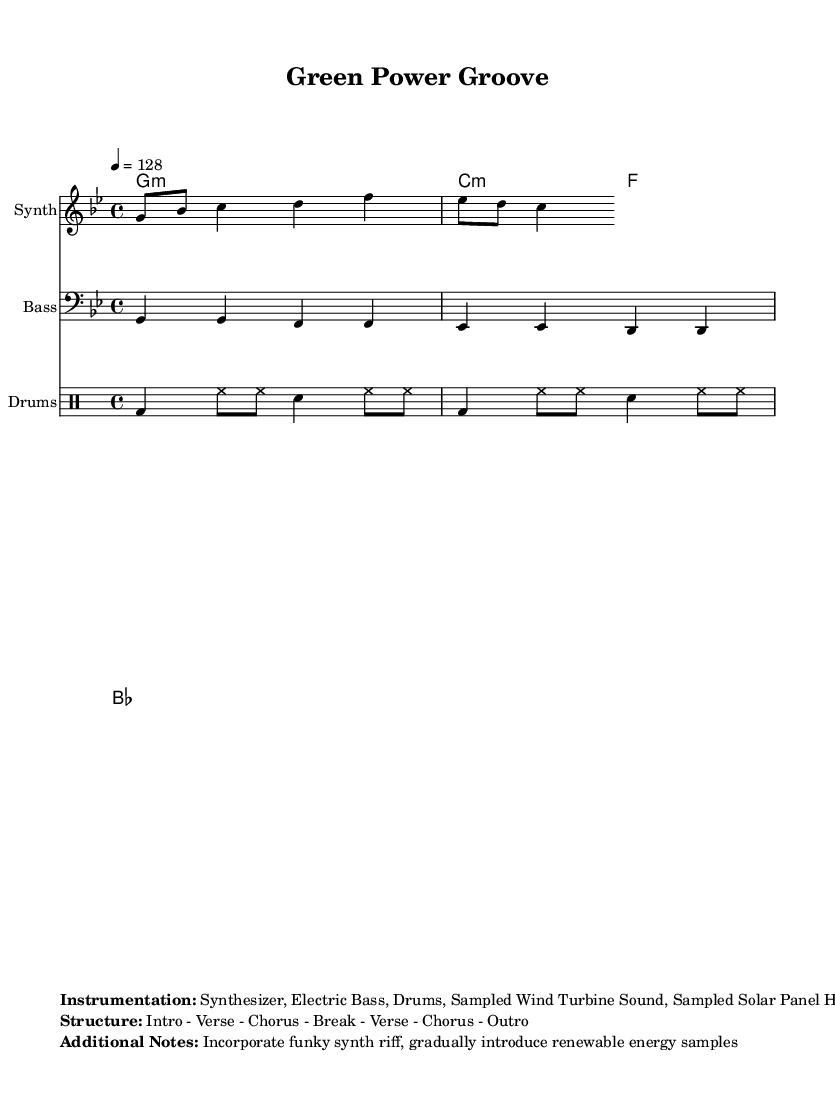What is the key signature of this music? The key signature is G minor, which contains two flats. This is determined by looking at the key signature indicated at the beginning of the sheet music, which shows two flats on the staff.
Answer: G minor What is the time signature of the piece? The time signature is 4/4, which means there are four beats in each measure and the quarter note gets one beat. This can be identified at the beginning of the score, where the time signature is written.
Answer: 4/4 What is the tempo of the music? The tempo marking indicates a speed of 128 beats per minute. This information is found in the tempo indication at the start of the score, specifying the speed at which the piece should be played.
Answer: 128 How many sections are in the structure of the piece? The structure consists of 7 sections: Intro, Verse, Chorus, Break, Verse, Chorus, and Outro. This is outlined in the additional notes at the bottom of the sheet music, summarizing the overall form.
Answer: 7 What instruments are used in this piece? The instrumentation includes a Synthesizer, Electric Bass, Drums, and sampled sounds from Wind Turbines and Solar Panels. This is detailed in the instrumentation section of the markup at the end of the score.
Answer: Synthesizer, Electric Bass, Drums, Sampled Wind Turbine Sound, Sampled Solar Panel Hum What type of musical genre does this piece represent? This piece is representative of Funky House music, which is indicated by the title and the use of specific rhythmic and sampling techniques typical of this genre. The title "Green Power Groove" suggests a fusion of funk elements and house rhythms.
Answer: Funky House What is the primary bass note for the melody? The primary bass notes in the melody are G, F, and E flat, which can be determined by analyzing the bass line notated in the staff and its tonal foundation throughout the measures.
Answer: G, F, E flat 